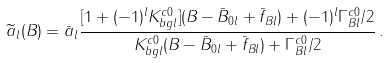<formula> <loc_0><loc_0><loc_500><loc_500>\widetilde { a } _ { l } ( B ) = \bar { a } _ { l } \frac { [ 1 + ( - 1 ) ^ { l } K ^ { c 0 } _ { b g l } ] ( B - \bar { B } _ { 0 l } + \bar { f } _ { B l } ) + ( - 1 ) ^ { l } \Gamma ^ { c 0 } _ { B l } / 2 } { K ^ { c 0 } _ { b g l } ( B - \bar { B } _ { 0 l } + \bar { f } _ { B l } ) + \Gamma ^ { c 0 } _ { B l } / 2 } \, .</formula> 